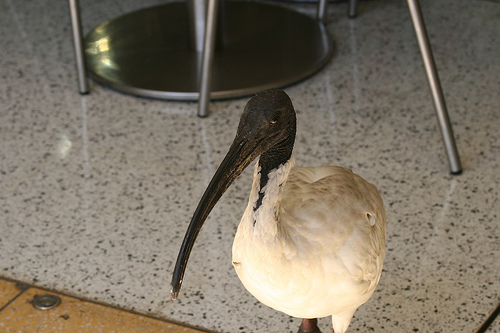What species of bird is this? This bird appears to be an ibis, recognizable by its long, down-curved beak and its overall body shape. What is it doing indoors? It's not uncommon for birds, such as ibises, to enter open buildings, especially in urban areas where they've adapted to human presence. It might be seeking food or shelter. 